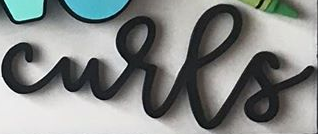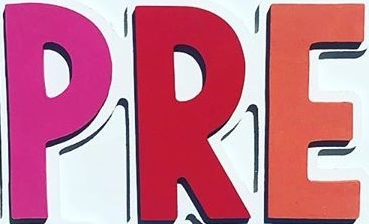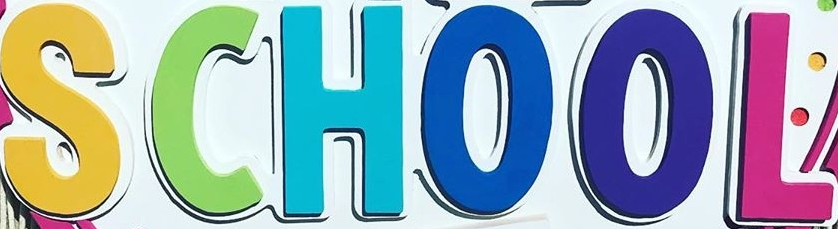Read the text from these images in sequence, separated by a semicolon. curls; PRE; SCHOOL 